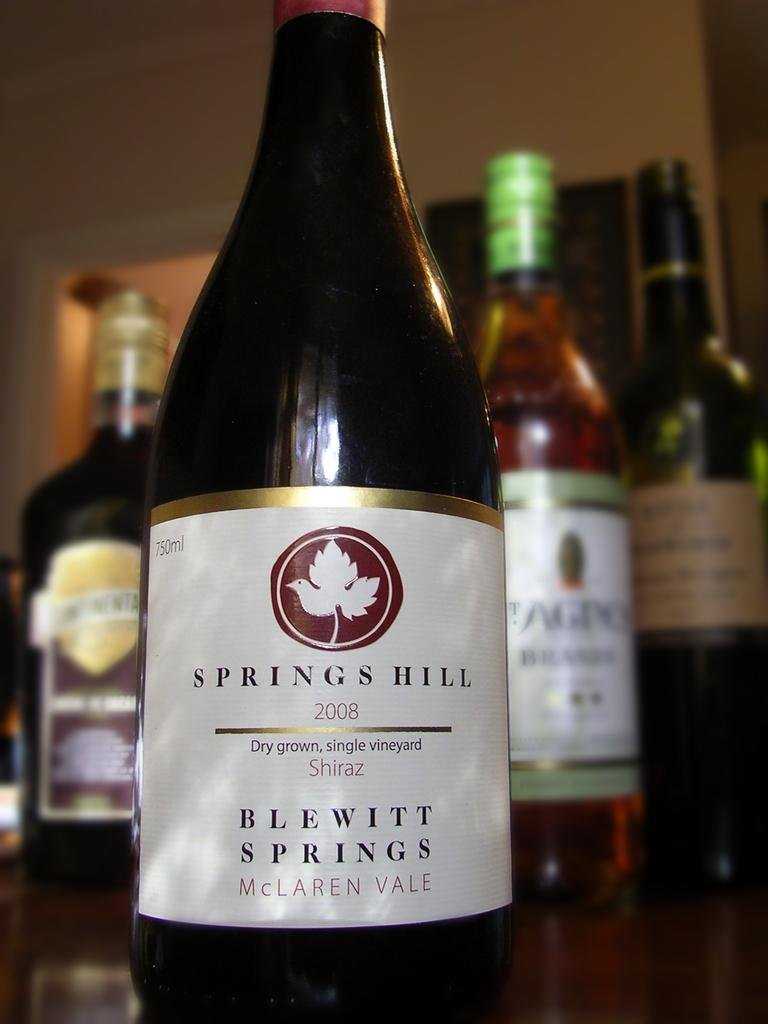What is the main object in the image? There is a wine bottle in the image. Where is the wine bottle located? The wine bottle is placed on a table. What else can be seen in the background of the image? There are bottles and a wall in the background of the image. What type of marble is being used to build the planes in the image? There are no planes or marble present in the image; it features a wine bottle on a table with bottles and a wall in the background. 